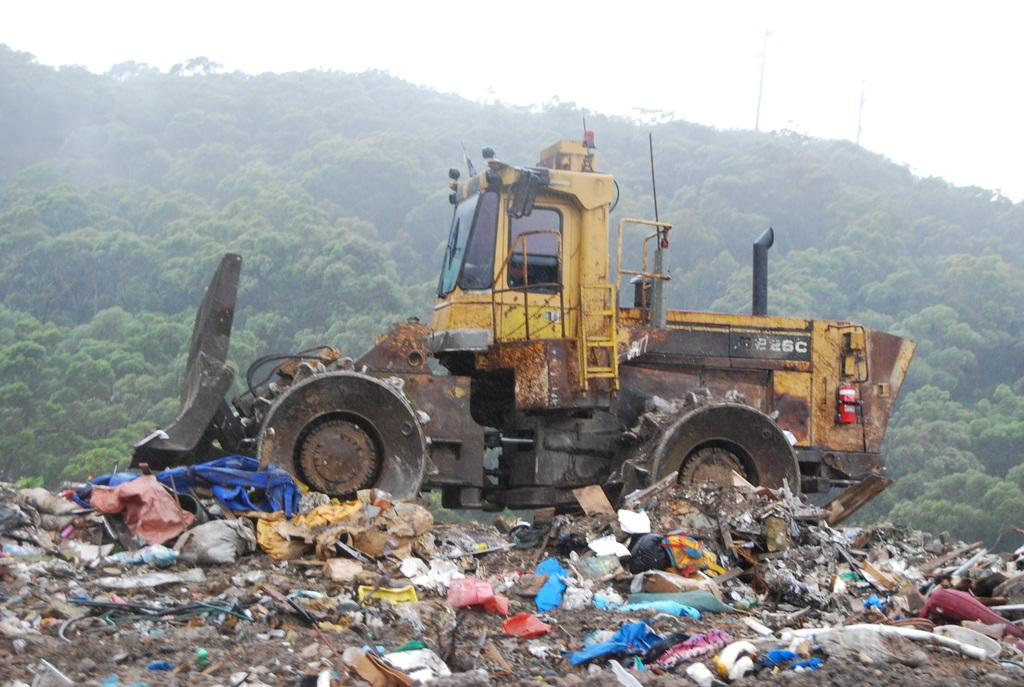What type of vehicle is present in the image? There is a bulldozer in the image. What is the bulldozer interacting with in the image? The bulldozer is interacting with garbage in the image. What type of vegetation can be seen in the image? There are trees in the image. What is visible in the background of the image? The sky is visible in the image. How does the bulldozer provide support to the trees in the image? The bulldozer does not provide support to the trees in the image; it is interacting with garbage. 